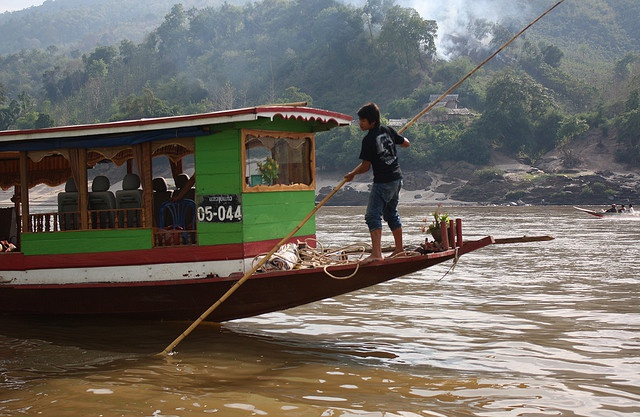Describe the objects in this image and their specific colors. I can see boat in lavender, black, maroon, darkgreen, and darkgray tones, people in lavender, black, maroon, gray, and darkgray tones, chair in lavender, black, and gray tones, chair in lavender and black tones, and chair in lavender, black, and gray tones in this image. 